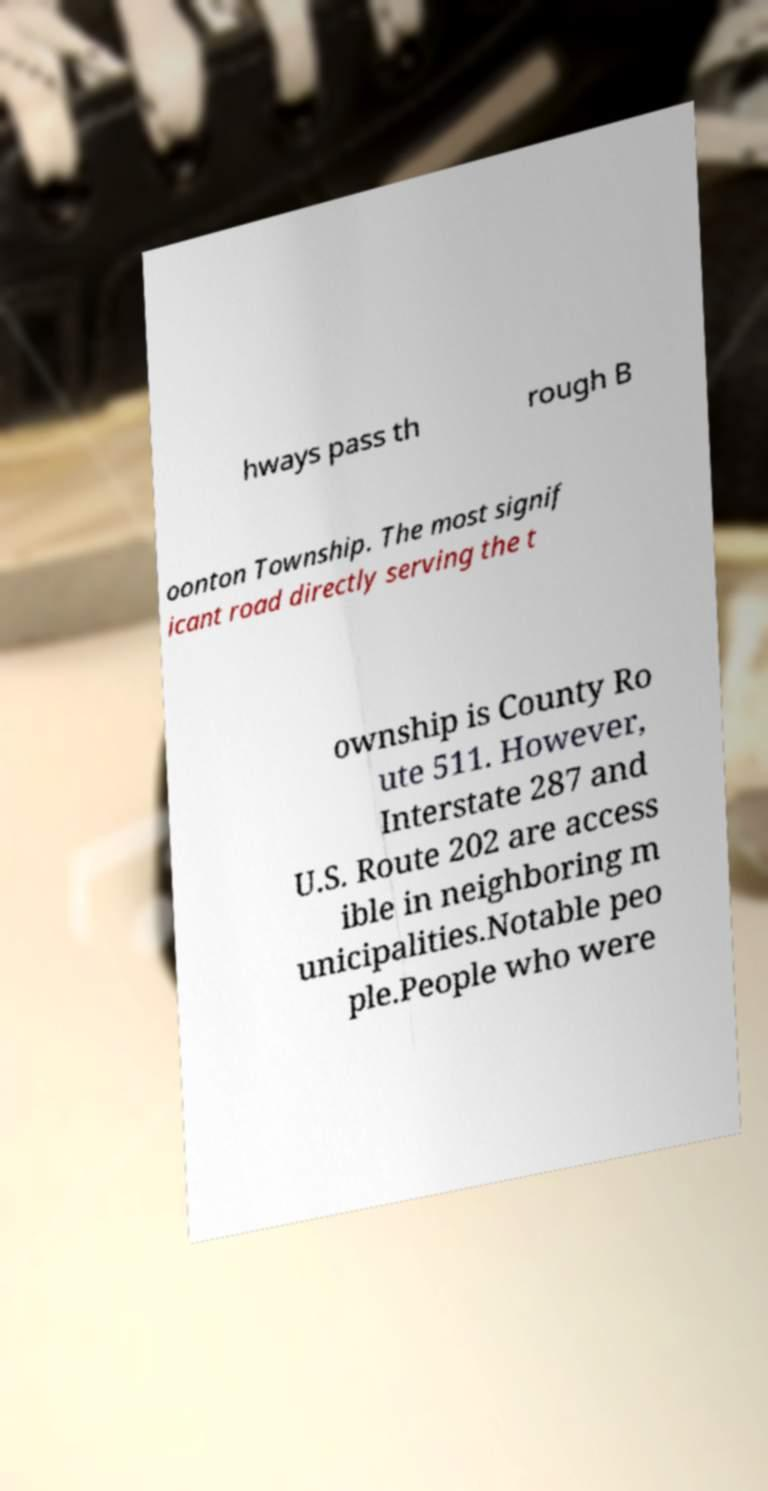I need the written content from this picture converted into text. Can you do that? hways pass th rough B oonton Township. The most signif icant road directly serving the t ownship is County Ro ute 511. However, Interstate 287 and U.S. Route 202 are access ible in neighboring m unicipalities.Notable peo ple.People who were 